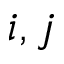<formula> <loc_0><loc_0><loc_500><loc_500>i , j</formula> 